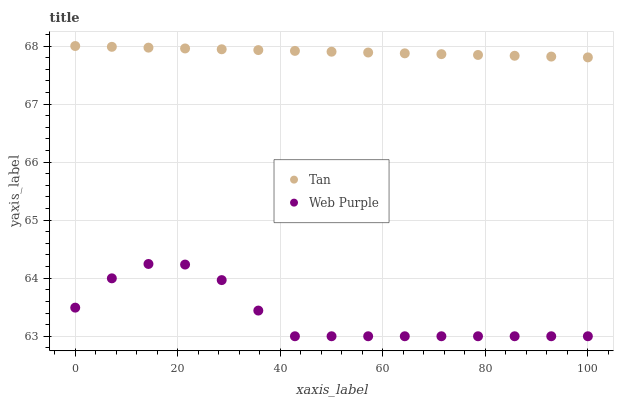Does Web Purple have the minimum area under the curve?
Answer yes or no. Yes. Does Tan have the maximum area under the curve?
Answer yes or no. Yes. Does Web Purple have the maximum area under the curve?
Answer yes or no. No. Is Tan the smoothest?
Answer yes or no. Yes. Is Web Purple the roughest?
Answer yes or no. Yes. Is Web Purple the smoothest?
Answer yes or no. No. Does Web Purple have the lowest value?
Answer yes or no. Yes. Does Tan have the highest value?
Answer yes or no. Yes. Does Web Purple have the highest value?
Answer yes or no. No. Is Web Purple less than Tan?
Answer yes or no. Yes. Is Tan greater than Web Purple?
Answer yes or no. Yes. Does Web Purple intersect Tan?
Answer yes or no. No. 